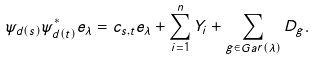Convert formula to latex. <formula><loc_0><loc_0><loc_500><loc_500>\psi _ { d ( s ) } \psi _ { d ( t ) } ^ { * } e _ { \lambda } = c _ { s , t } e _ { \lambda } + \sum _ { i = 1 } ^ { n } Y _ { i } + \sum _ { g \in G a r ( \lambda ) } D _ { g } .</formula> 